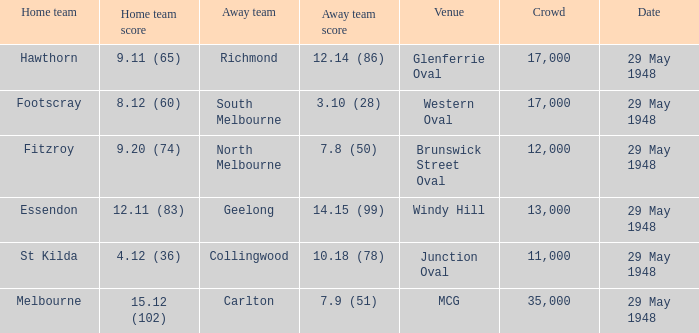In the match where north melbourne was the away team, how much did the home team score? 9.20 (74). 